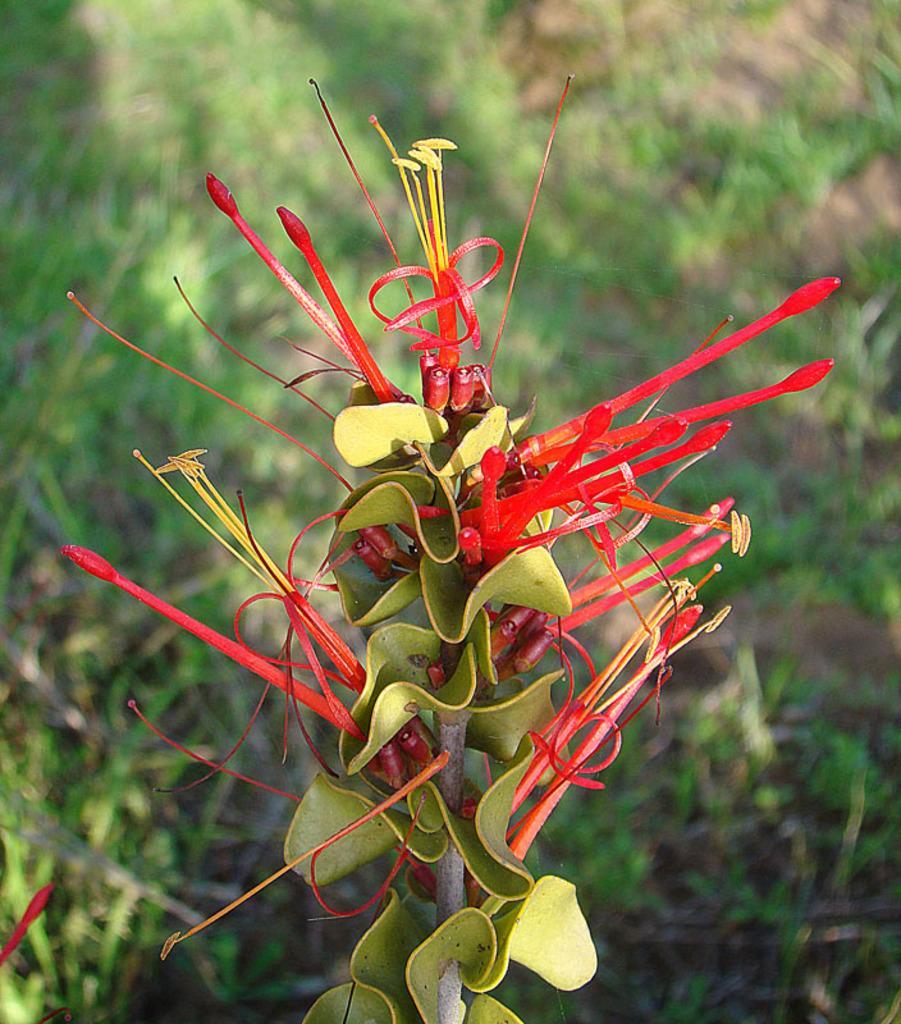Could you give a brief overview of what you see in this image? In this picture I can see some red buds on the plant, beside that I can see some green leaves. In the back I can see the grass on the ground. 